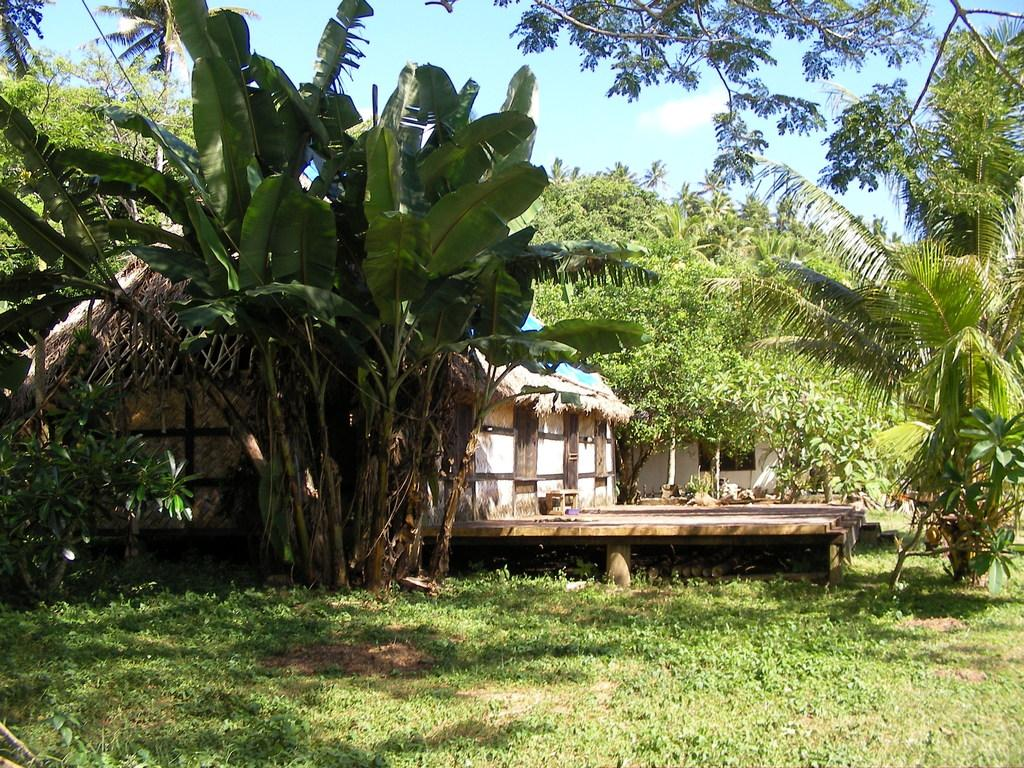What type of structure can be seen in the background of the image? There is a building in the backdrop of the image. What is covering the ground in the image? There is grass on the floor in the image. What other natural elements can be seen in the background of the image? There are trees in the backdrop of the image. How would you describe the weather based on the image? The sky is clear in the image, suggesting good weather or a clear day}. Can you see any flames coming from the building in the image? There are no flames visible in the image; the building and surrounding elements are not on fire. How many brothers are present in the image? There is no mention of any people, let alone brothers, in the image. 